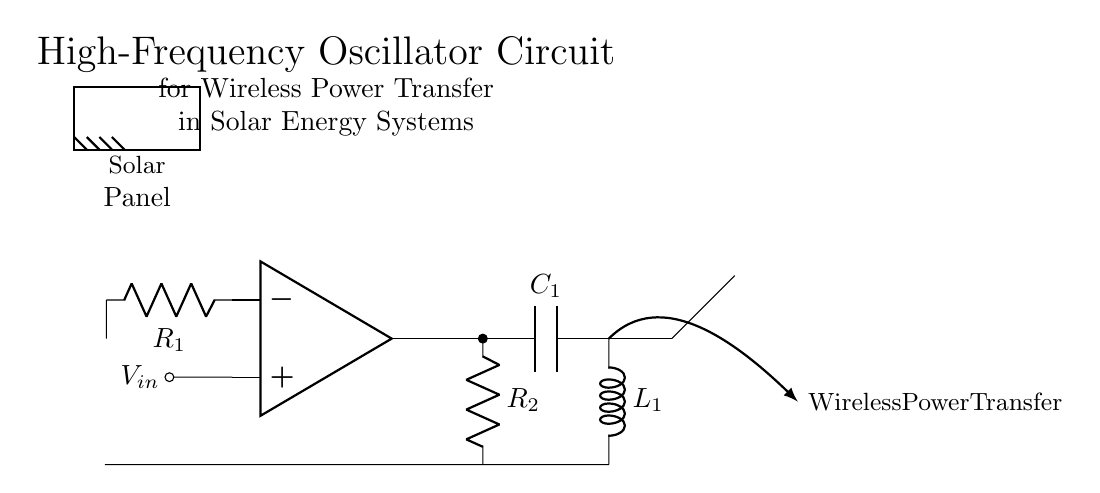What is the main active component in this circuit? The main active component is the operational amplifier, which is used to amplify the input signal.
Answer: operational amplifier What are the passive components present in the circuit? The passive components are resistors, a capacitor, and an inductor, which are used for various functions such as filtering and tuning.
Answer: resistors, capacitor, inductor What is the purpose of the capacitor in this oscillator circuit? The capacitor stores energy and helps to determine the frequency of oscillation by working in conjunction with the inductor.
Answer: frequency determination What does the antenna symbol represent in this circuit? The antenna symbol indicates the part of the circuit used for wireless power transfer, where the oscillating electromagnetic field is transmitted.
Answer: wireless power transfer How many resistors are there in this circuit? There are two resistors, labeled as R1 and R2, which are part of the feedback and output stages of the oscillator.
Answer: two Explain the role of the solar panel in this circuit setup. The solar panel provides the initial input voltage to energize the circuit, allowing the oscillator to function and power the wireless transfer.
Answer: input voltage supply What is the expected function of this oscillator circuit in solar energy systems? The expected function is to convert the DC output from the solar panel into a high-frequency AC signal for efficient wireless transfer of power.
Answer: high-frequency AC signal generation 